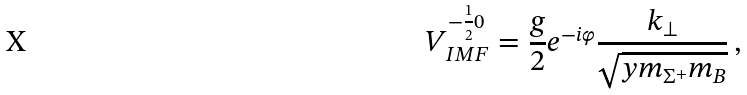Convert formula to latex. <formula><loc_0><loc_0><loc_500><loc_500>V _ { I M F } ^ { - \frac { 1 } { 2 } 0 } = \frac { g } { 2 } e ^ { - i \varphi } \frac { k _ { \perp } } { \sqrt { y m _ { \Sigma ^ { + } } m _ { B } } } \, ,</formula> 